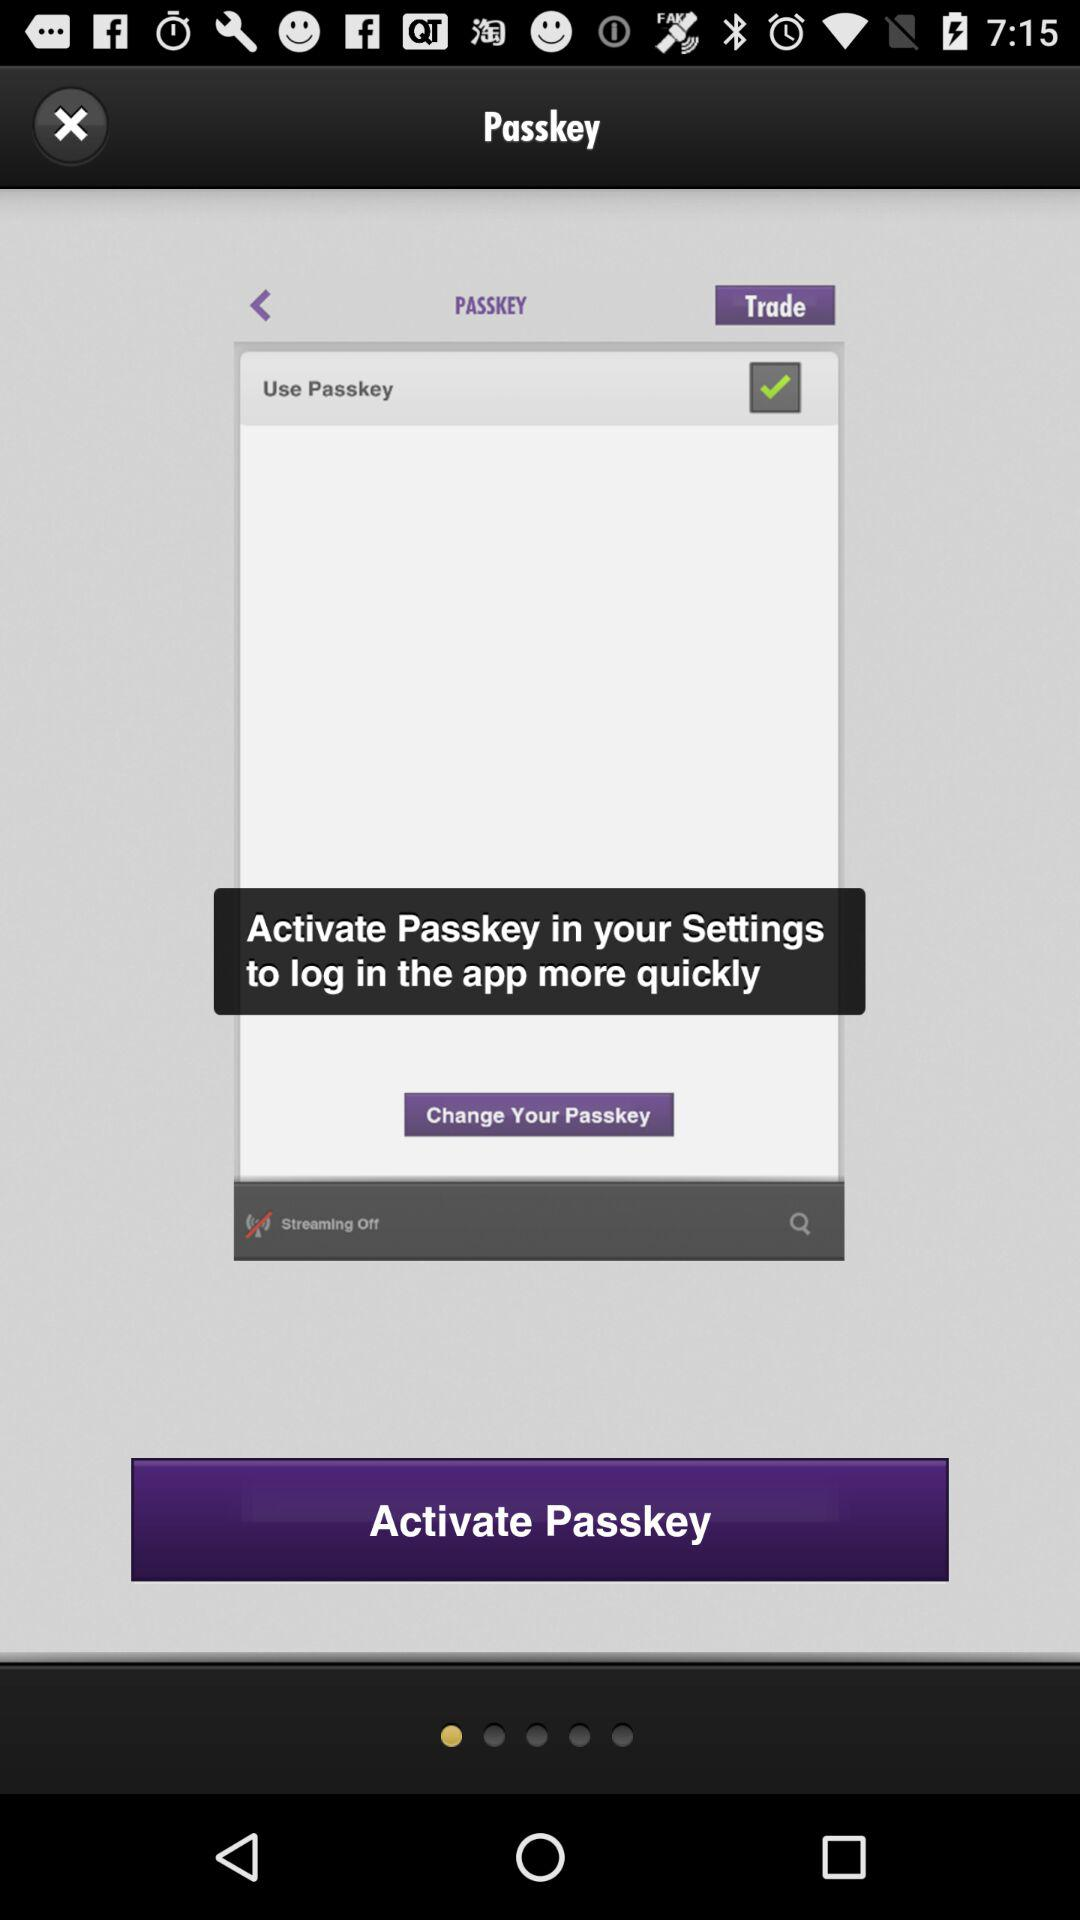What is the status of the "Use Passkey" setting? The status is "on". 